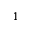Convert formula to latex. <formula><loc_0><loc_0><loc_500><loc_500>_ { 1 }</formula> 